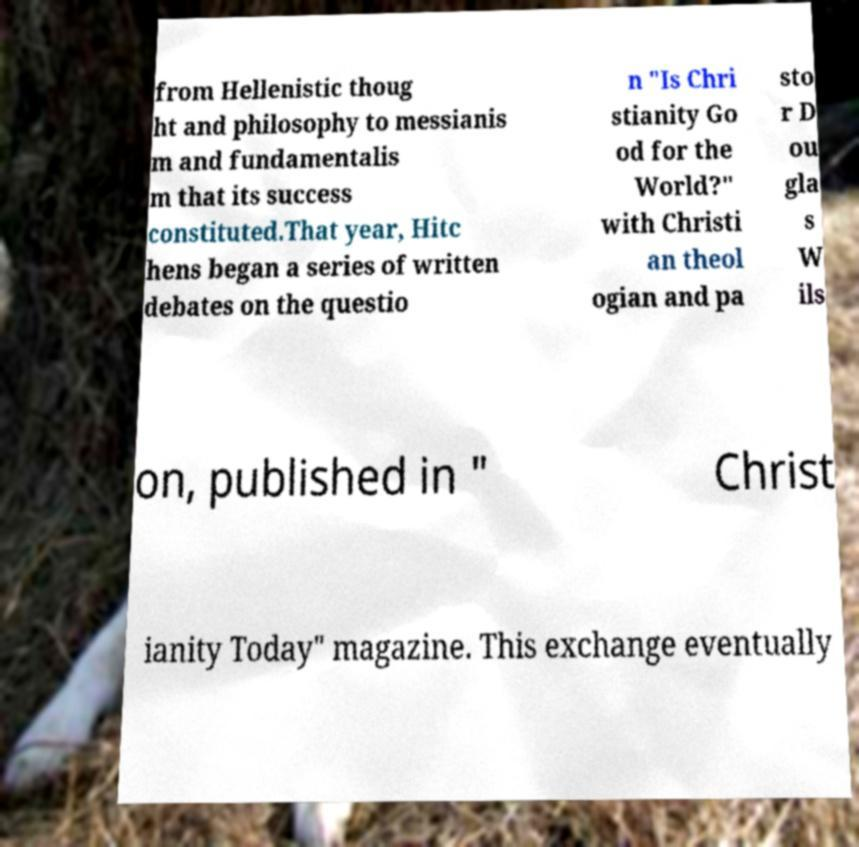Could you assist in decoding the text presented in this image and type it out clearly? from Hellenistic thoug ht and philosophy to messianis m and fundamentalis m that its success constituted.That year, Hitc hens began a series of written debates on the questio n "Is Chri stianity Go od for the World?" with Christi an theol ogian and pa sto r D ou gla s W ils on, published in " Christ ianity Today" magazine. This exchange eventually 